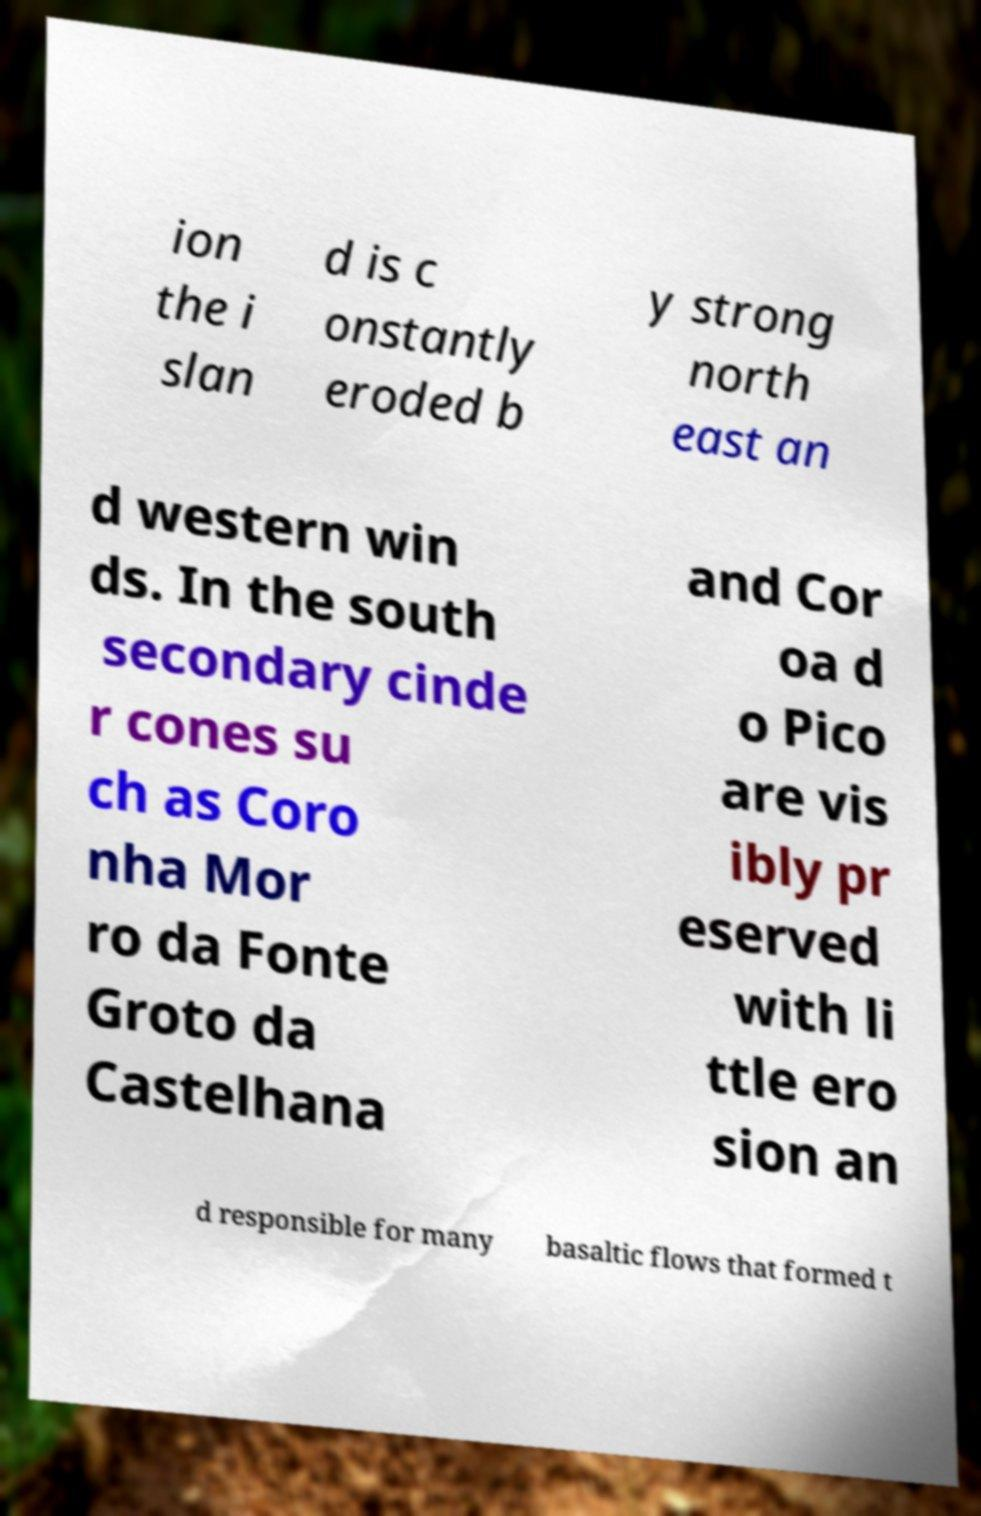What messages or text are displayed in this image? I need them in a readable, typed format. ion the i slan d is c onstantly eroded b y strong north east an d western win ds. In the south secondary cinde r cones su ch as Coro nha Mor ro da Fonte Groto da Castelhana and Cor oa d o Pico are vis ibly pr eserved with li ttle ero sion an d responsible for many basaltic flows that formed t 